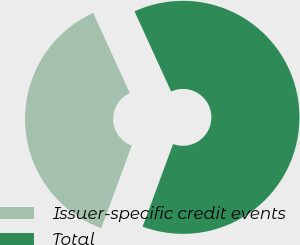<chart> <loc_0><loc_0><loc_500><loc_500><pie_chart><fcel>Issuer-specific credit events<fcel>Total<nl><fcel>37.56%<fcel>62.44%<nl></chart> 